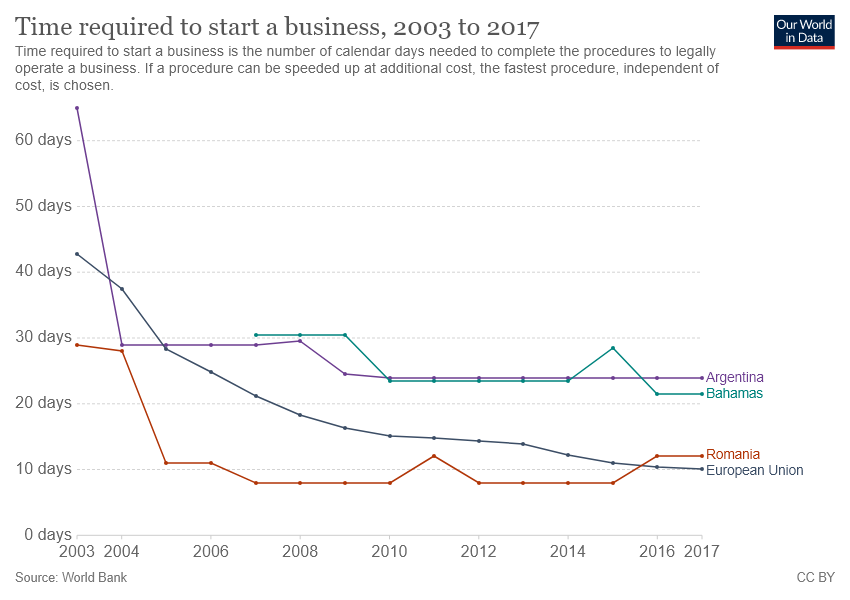List a handful of essential elements in this visual. The sum of the values of all lines reaches its peak at some point between 2003 and 2005. The chart includes four countries/regions. 